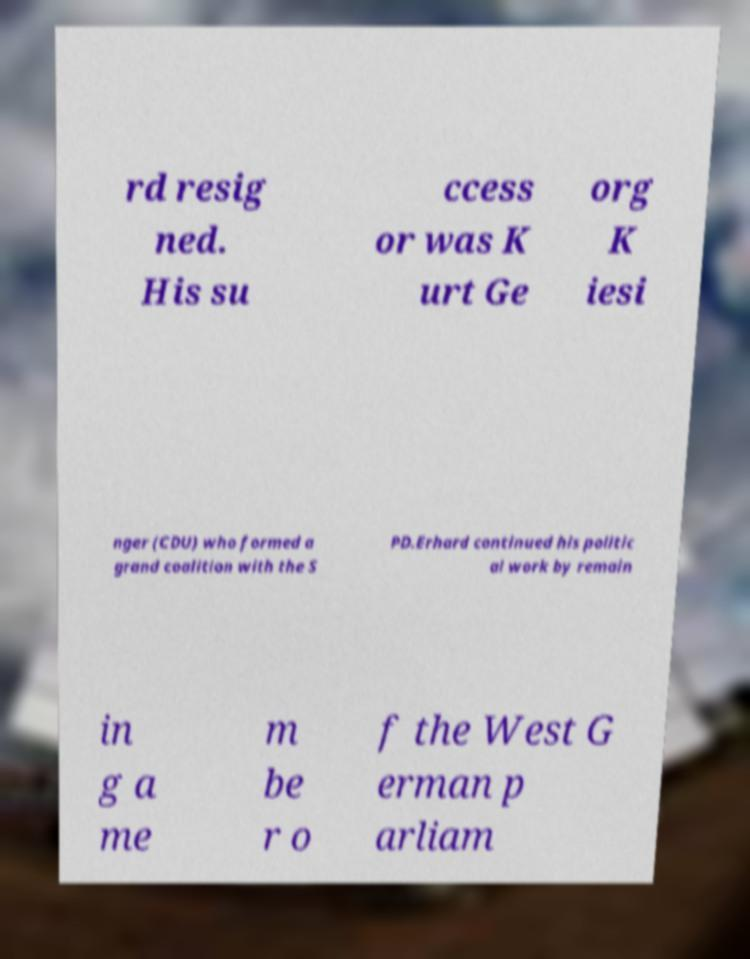Can you accurately transcribe the text from the provided image for me? rd resig ned. His su ccess or was K urt Ge org K iesi nger (CDU) who formed a grand coalition with the S PD.Erhard continued his politic al work by remain in g a me m be r o f the West G erman p arliam 